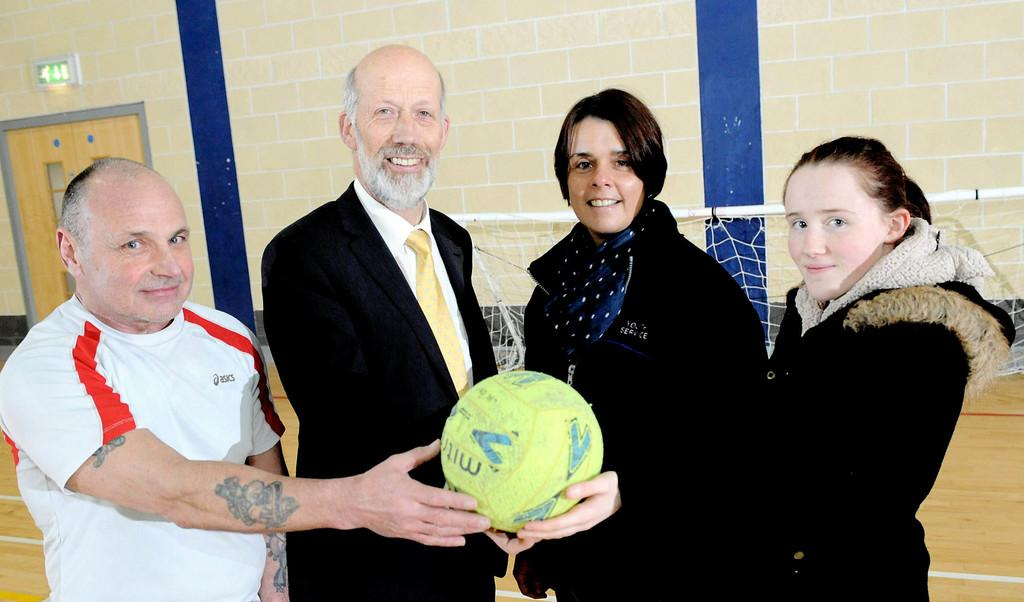How many people are in the image? There are four persons in the image. What are the four persons holding? The four persons are holding a green ball. What color is the background wall in the image? The background wall is creme in color. What grade is the language spoken by the persons in the image? There is no indication of language spoken by the persons in the image, and therefore no grade can be determined. 